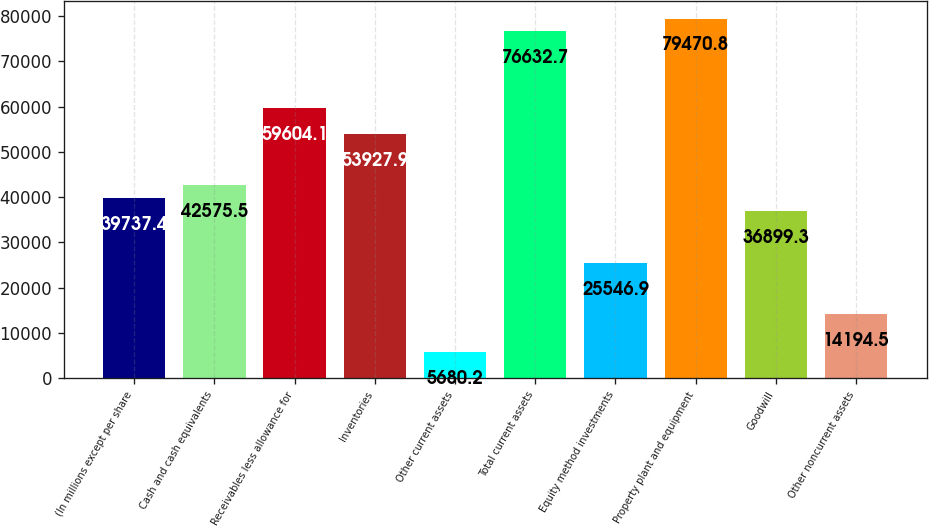Convert chart to OTSL. <chart><loc_0><loc_0><loc_500><loc_500><bar_chart><fcel>(In millions except per share<fcel>Cash and cash equivalents<fcel>Receivables less allowance for<fcel>Inventories<fcel>Other current assets<fcel>Total current assets<fcel>Equity method investments<fcel>Property plant and equipment<fcel>Goodwill<fcel>Other noncurrent assets<nl><fcel>39737.4<fcel>42575.5<fcel>59604.1<fcel>53927.9<fcel>5680.2<fcel>76632.7<fcel>25546.9<fcel>79470.8<fcel>36899.3<fcel>14194.5<nl></chart> 